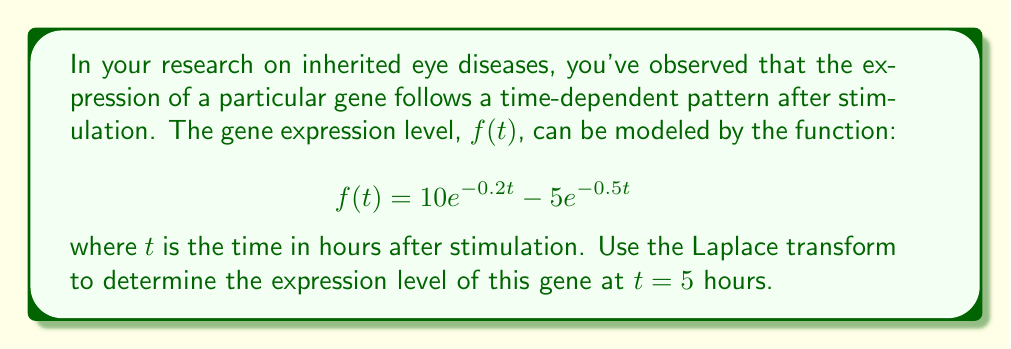Give your solution to this math problem. To solve this problem, we'll follow these steps:

1) First, recall the Laplace transform of an exponential function:
   $$\mathcal{L}\{e^{at}\} = \frac{1}{s-a}$$

2) The Laplace transform of our function $f(t)$ is:
   $$F(s) = \mathcal{L}\{f(t)\} = 10\mathcal{L}\{e^{-0.2t}\} - 5\mathcal{L}\{e^{-0.5t}\}$$

3) Applying the Laplace transform:
   $$F(s) = \frac{10}{s+0.2} - \frac{5}{s+0.5}$$

4) To find the gene expression level at $t=5$, we need to use the inverse Laplace transform. However, we can simplify this process by using the property of the Laplace transform that multiplication by $e^{-st_0}$ in the s-domain corresponds to a time shift of $t_0$ in the time domain:

   $$\mathcal{L}^{-1}\{e^{-st_0}F(s)\} = f(t-t_0)u(t-t_0)$$

   where $u(t)$ is the unit step function.

5) In our case, we want $f(5)$, so we multiply $F(s)$ by $e^{-5s}$:

   $$e^{-5s}F(s) = \frac{10e^{-5s}}{s+0.2} - \frac{5e^{-5s}}{s+0.5}$$

6) Now, we can use the inverse Laplace transform:

   $$f(5) = 10e^{-0.2(5)} - 5e^{-0.5(5)}$$

7) Calculate the values:
   $$f(5) = 10e^{-1} - 5e^{-2.5}$$
   $$f(5) = 10(0.3679) - 5(0.0821)$$
   $$f(5) = 3.679 - 0.4105$$
   $$f(5) = 3.2685$$

Therefore, the gene expression level at $t = 5$ hours is approximately 3.2685 units.
Answer: The gene expression level at $t = 5$ hours is approximately 3.2685 units. 